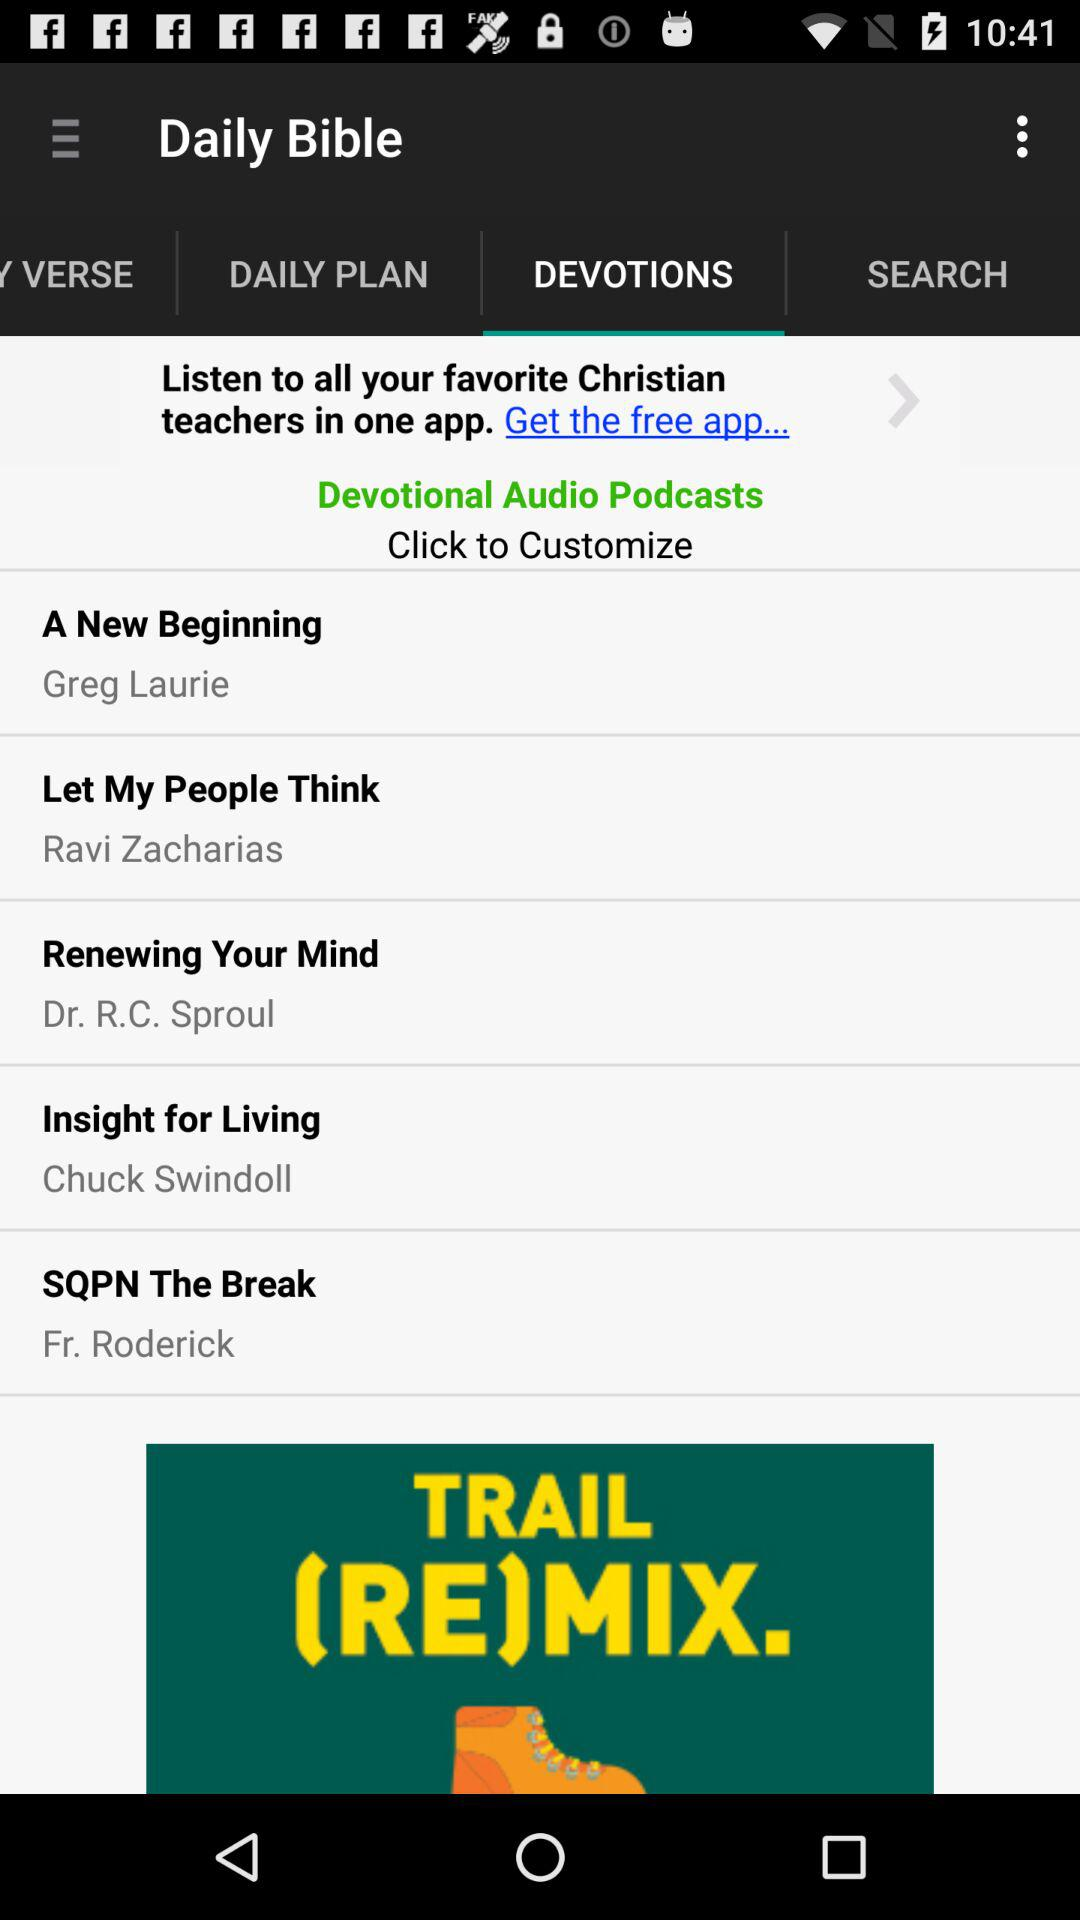What is the name of the podcast by Fr. Roderick? The name of the podcast is "SQPN The Break". 